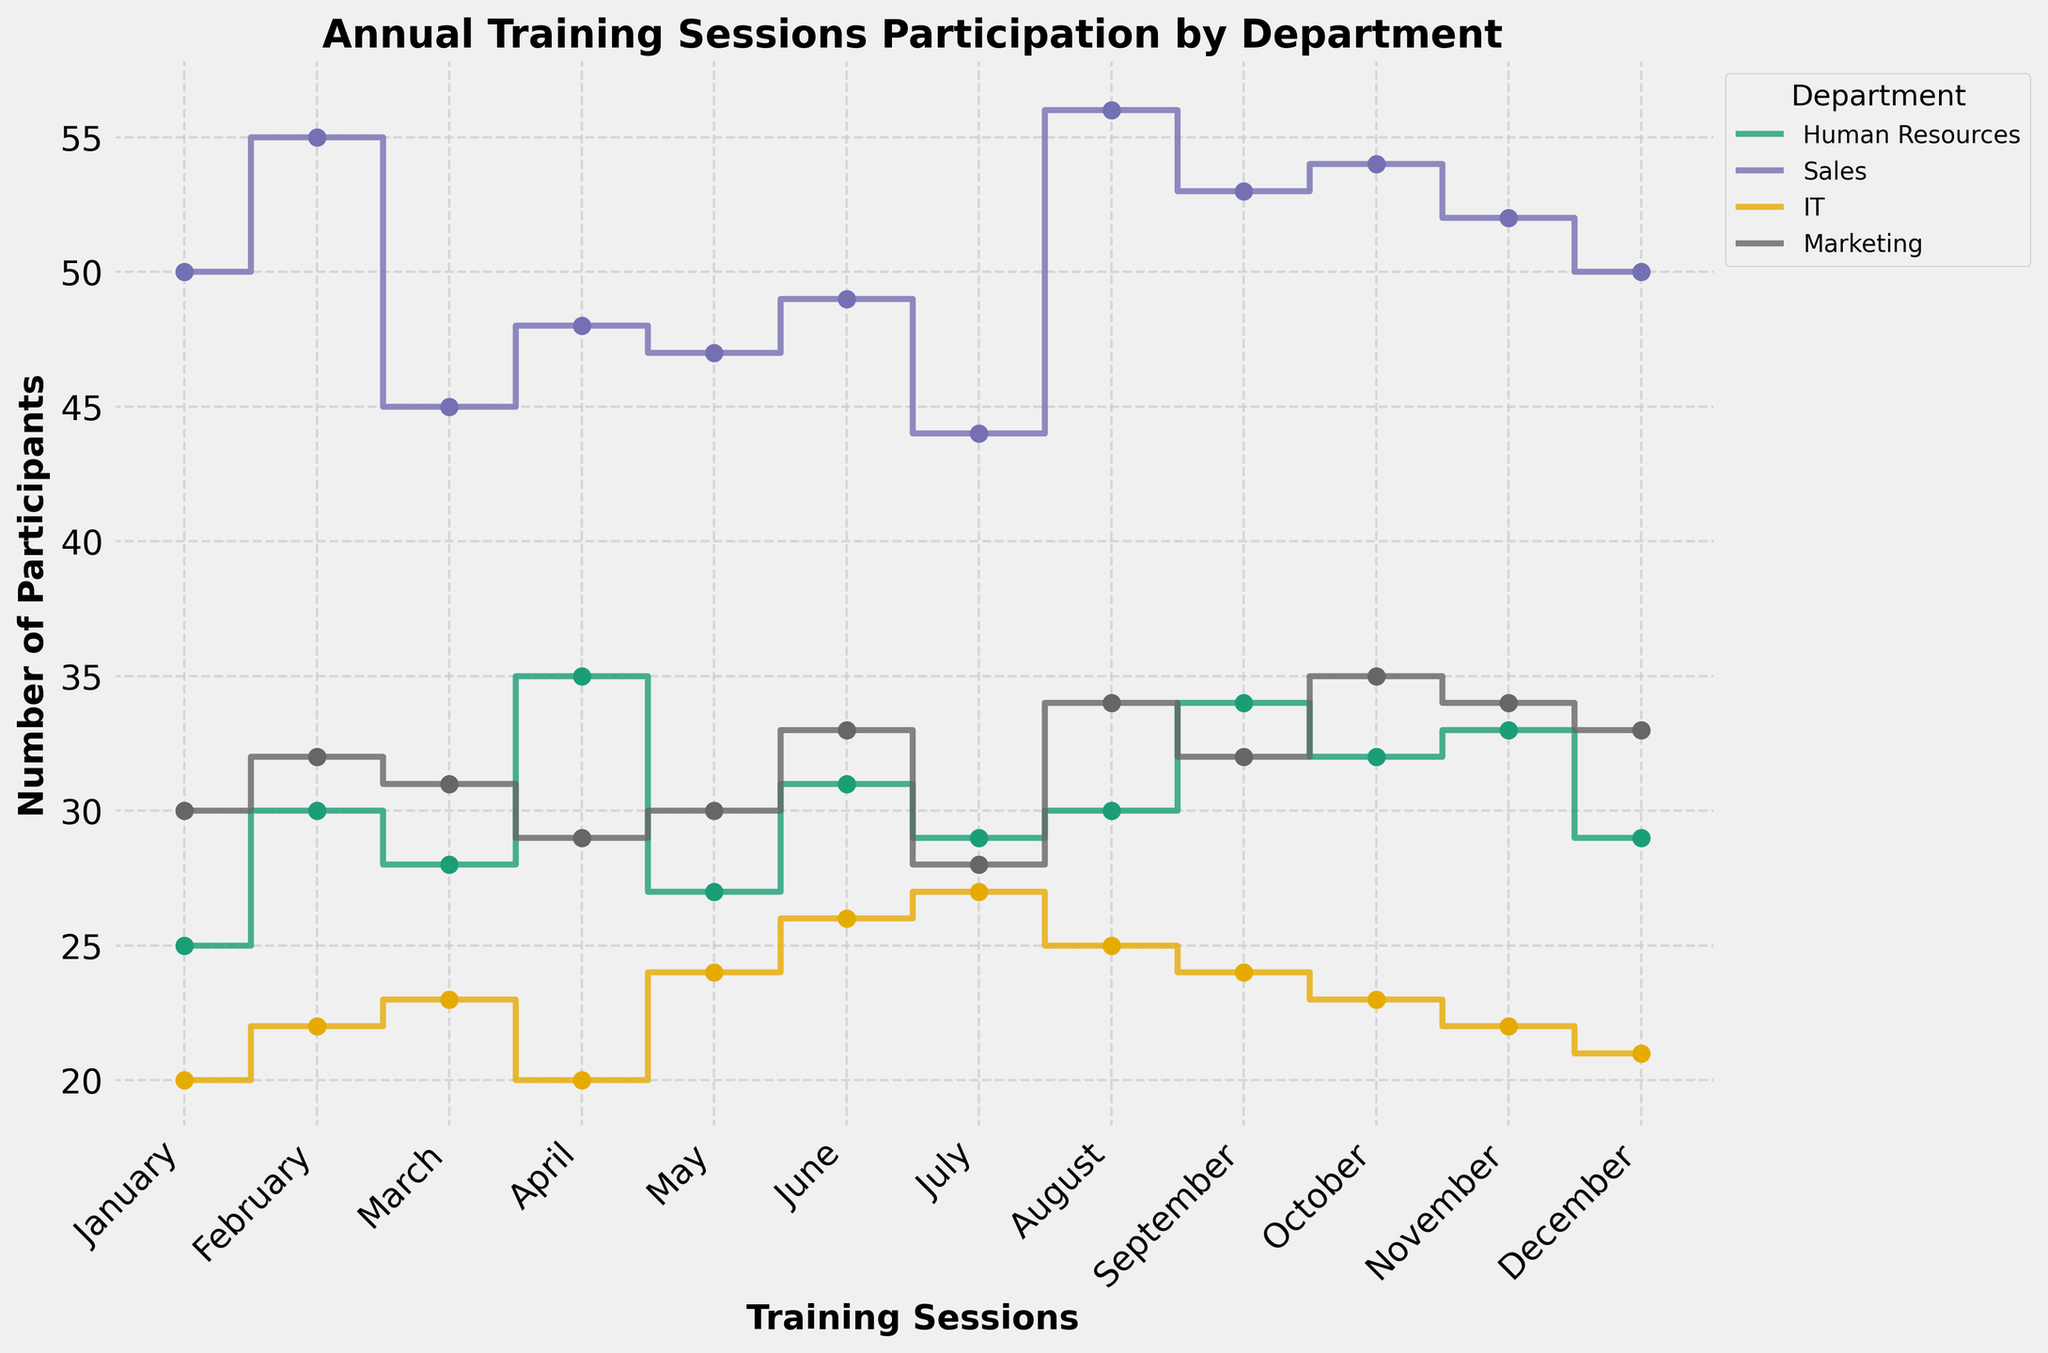What is the title of the figure? The title is typically located at the top of the figure in bold text.
Answer: Annual Training Sessions Participation by Department Which department had the highest number of participants in August? Look at the data points for August and identify which department has the highest value. Sales has 56 participants which is the highest compared to other departments.
Answer: Sales How many participants attended the training sessions for the Human Resources department in February? Find the February data point for Human Resources and read the corresponding value. It shows 30 participants.
Answer: 30 Which month had the least participation from the IT department? Compare the values for the IT department across all months and identify the smallest value, which is in January with 20 participants.
Answer: January What is the average number of participants in the Marketing department between January and June? Sum the participants from January (30), February (32), March (31), April (29), May (30), and June (33) and divide by 6: (30 + 32 + 31 + 29 + 30 + 33) / 6 = 185 / 6 = 30.83
Answer: 30.83 In which months did the Sales department have more participants than the IT department? Compare month-by-month the participant values of the Sales and IT departments; months where Sales figures are higher: January, February, March, April, May, June, July, August, September, October, November, December.
Answer: January, February, March, April, May, June, July, August, September, October, November, December By how many participants did the Marketing department surpass the Human Resources department in October? Subtract the number of Human Resources participants in October (32) from the number of Marketing participants in October (35): 35 - 32 = 3
Answer: 3 Identify the trend in the number of participants for each department over the year. Determine whether the trend for each department is increasing, decreasing, or stable by looking at the overall changes from January to December.
Answer: Human Resources: fluctuates; Sales: fluctuates; IT: slightly decreases; Marketing: fluctuates What is the total number of participants in the Sales department for the whole year? Sum the number of participants in the Sales department from January to December: 50 + 55 + 45 + 48 + 47 + 49 + 44 + 56 + 53 + 54 + 52 + 50 = 603
Answer: 603 